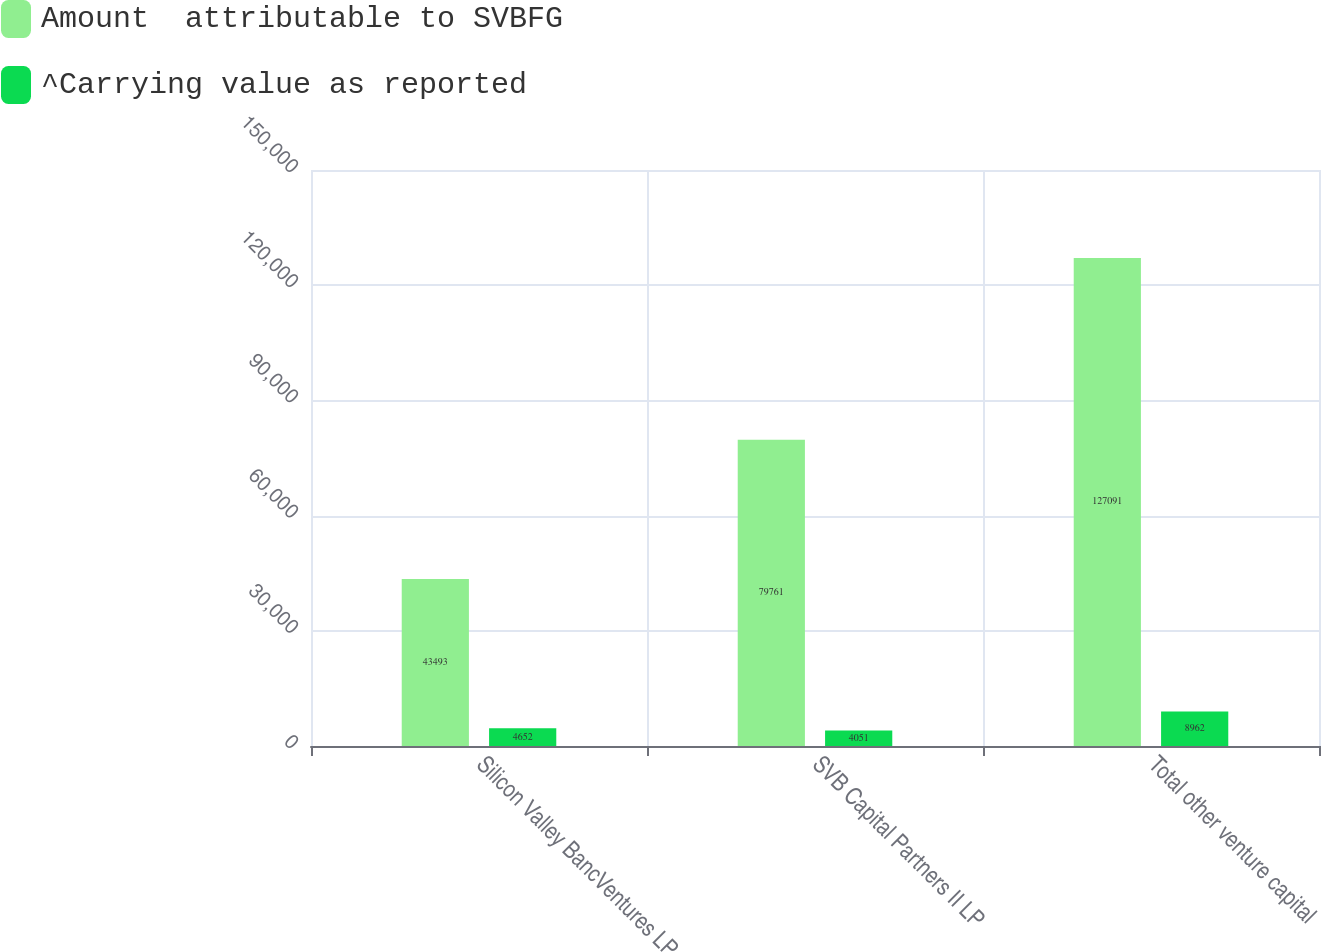<chart> <loc_0><loc_0><loc_500><loc_500><stacked_bar_chart><ecel><fcel>Silicon Valley BancVentures LP<fcel>SVB Capital Partners II LP<fcel>Total other venture capital<nl><fcel>Amount  attributable to SVBFG<fcel>43493<fcel>79761<fcel>127091<nl><fcel>^Carrying value as reported<fcel>4652<fcel>4051<fcel>8962<nl></chart> 